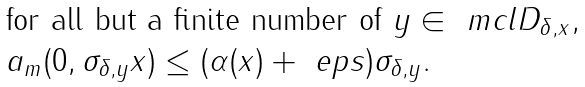<formula> <loc_0><loc_0><loc_500><loc_500>\begin{array} { l } \text {for all but a finite number of } y \in \ m c l { D } _ { \delta , x } , \\ a _ { m } ( 0 , \sigma _ { \delta , y } x ) \leq ( \alpha ( x ) + \ e p s ) \sigma _ { \delta , y } . \end{array}</formula> 